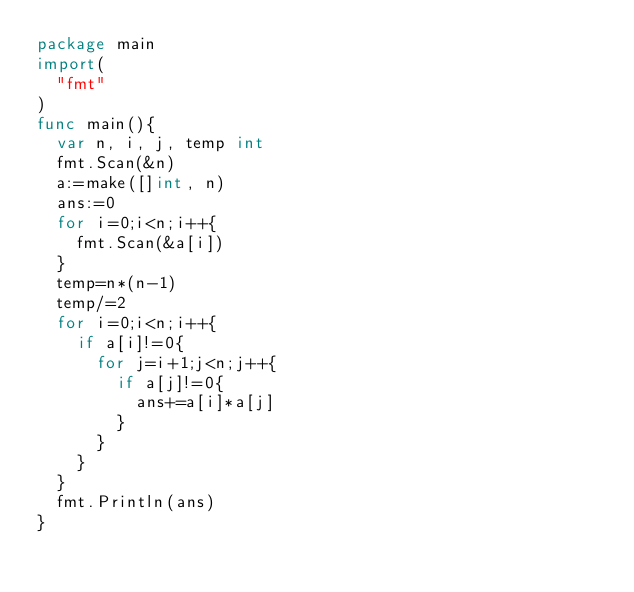<code> <loc_0><loc_0><loc_500><loc_500><_Go_>package main
import(
  "fmt"
)
func main(){
  var n, i, j, temp int
  fmt.Scan(&n)
  a:=make([]int, n)
  ans:=0
  for i=0;i<n;i++{
    fmt.Scan(&a[i])
  }
  temp=n*(n-1)
  temp/=2
  for i=0;i<n;i++{
    if a[i]!=0{
      for j=i+1;j<n;j++{
        if a[j]!=0{
          ans+=a[i]*a[j]
        }
      }
    }
  }
  fmt.Println(ans)
}
</code> 